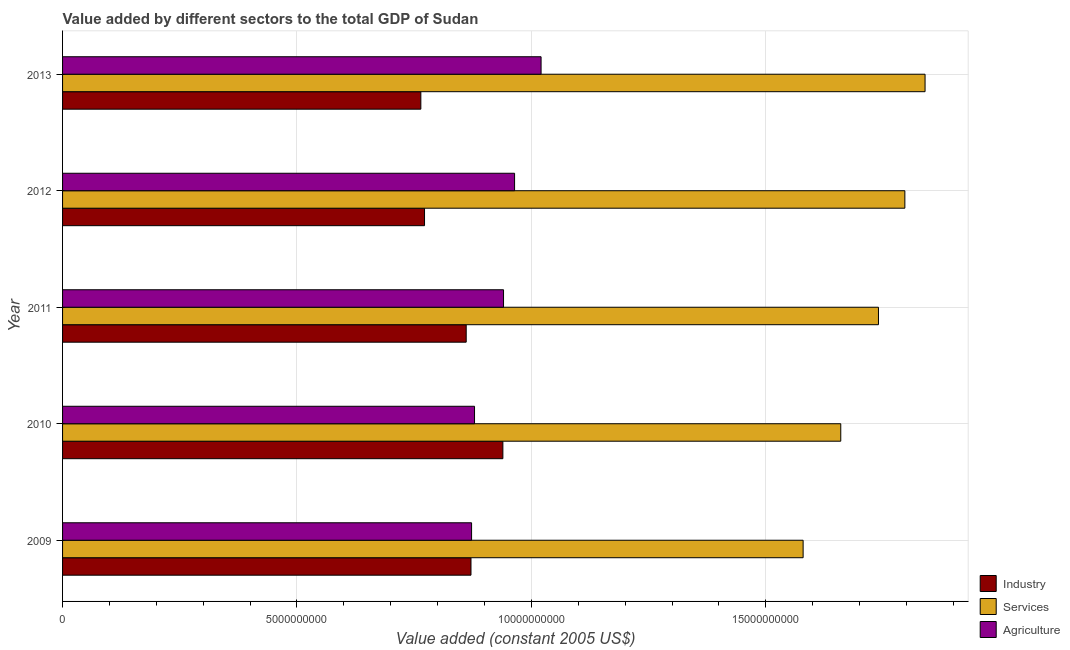How many different coloured bars are there?
Your response must be concise. 3. How many groups of bars are there?
Give a very brief answer. 5. Are the number of bars per tick equal to the number of legend labels?
Your answer should be very brief. Yes. How many bars are there on the 2nd tick from the top?
Your answer should be very brief. 3. What is the label of the 4th group of bars from the top?
Offer a terse response. 2010. In how many cases, is the number of bars for a given year not equal to the number of legend labels?
Make the answer very short. 0. What is the value added by services in 2013?
Provide a short and direct response. 1.84e+1. Across all years, what is the maximum value added by agricultural sector?
Provide a succinct answer. 1.02e+1. Across all years, what is the minimum value added by services?
Give a very brief answer. 1.58e+1. In which year was the value added by services minimum?
Your response must be concise. 2009. What is the total value added by industrial sector in the graph?
Your response must be concise. 4.21e+1. What is the difference between the value added by services in 2011 and that in 2013?
Offer a terse response. -9.94e+08. What is the difference between the value added by agricultural sector in 2010 and the value added by services in 2012?
Give a very brief answer. -9.18e+09. What is the average value added by industrial sector per year?
Keep it short and to the point. 8.41e+09. In the year 2013, what is the difference between the value added by services and value added by industrial sector?
Keep it short and to the point. 1.08e+1. In how many years, is the value added by industrial sector greater than 16000000000 US$?
Your answer should be very brief. 0. Is the difference between the value added by industrial sector in 2010 and 2012 greater than the difference between the value added by services in 2010 and 2012?
Give a very brief answer. Yes. What is the difference between the highest and the second highest value added by services?
Make the answer very short. 4.31e+08. What is the difference between the highest and the lowest value added by agricultural sector?
Offer a very short reply. 1.48e+09. Is the sum of the value added by agricultural sector in 2009 and 2012 greater than the maximum value added by services across all years?
Provide a short and direct response. No. What does the 2nd bar from the top in 2013 represents?
Make the answer very short. Services. What does the 3rd bar from the bottom in 2009 represents?
Your answer should be compact. Agriculture. How many bars are there?
Your response must be concise. 15. How many years are there in the graph?
Provide a short and direct response. 5. Does the graph contain any zero values?
Give a very brief answer. No. How many legend labels are there?
Your answer should be very brief. 3. What is the title of the graph?
Keep it short and to the point. Value added by different sectors to the total GDP of Sudan. What is the label or title of the X-axis?
Make the answer very short. Value added (constant 2005 US$). What is the Value added (constant 2005 US$) of Industry in 2009?
Your response must be concise. 8.71e+09. What is the Value added (constant 2005 US$) in Services in 2009?
Your answer should be compact. 1.58e+1. What is the Value added (constant 2005 US$) in Agriculture in 2009?
Offer a terse response. 8.72e+09. What is the Value added (constant 2005 US$) in Industry in 2010?
Provide a succinct answer. 9.39e+09. What is the Value added (constant 2005 US$) in Services in 2010?
Provide a short and direct response. 1.66e+1. What is the Value added (constant 2005 US$) in Agriculture in 2010?
Ensure brevity in your answer.  8.79e+09. What is the Value added (constant 2005 US$) of Industry in 2011?
Provide a succinct answer. 8.61e+09. What is the Value added (constant 2005 US$) of Services in 2011?
Your answer should be compact. 1.74e+1. What is the Value added (constant 2005 US$) in Agriculture in 2011?
Your answer should be compact. 9.41e+09. What is the Value added (constant 2005 US$) of Industry in 2012?
Offer a terse response. 7.72e+09. What is the Value added (constant 2005 US$) in Services in 2012?
Make the answer very short. 1.80e+1. What is the Value added (constant 2005 US$) in Agriculture in 2012?
Offer a terse response. 9.64e+09. What is the Value added (constant 2005 US$) of Industry in 2013?
Keep it short and to the point. 7.64e+09. What is the Value added (constant 2005 US$) in Services in 2013?
Ensure brevity in your answer.  1.84e+1. What is the Value added (constant 2005 US$) in Agriculture in 2013?
Offer a terse response. 1.02e+1. Across all years, what is the maximum Value added (constant 2005 US$) of Industry?
Your answer should be compact. 9.39e+09. Across all years, what is the maximum Value added (constant 2005 US$) in Services?
Ensure brevity in your answer.  1.84e+1. Across all years, what is the maximum Value added (constant 2005 US$) in Agriculture?
Your answer should be compact. 1.02e+1. Across all years, what is the minimum Value added (constant 2005 US$) in Industry?
Give a very brief answer. 7.64e+09. Across all years, what is the minimum Value added (constant 2005 US$) in Services?
Provide a succinct answer. 1.58e+1. Across all years, what is the minimum Value added (constant 2005 US$) of Agriculture?
Your answer should be compact. 8.72e+09. What is the total Value added (constant 2005 US$) of Industry in the graph?
Your answer should be compact. 4.21e+1. What is the total Value added (constant 2005 US$) in Services in the graph?
Your answer should be very brief. 8.62e+1. What is the total Value added (constant 2005 US$) of Agriculture in the graph?
Offer a terse response. 4.68e+1. What is the difference between the Value added (constant 2005 US$) in Industry in 2009 and that in 2010?
Give a very brief answer. -6.80e+08. What is the difference between the Value added (constant 2005 US$) in Services in 2009 and that in 2010?
Ensure brevity in your answer.  -8.03e+08. What is the difference between the Value added (constant 2005 US$) in Agriculture in 2009 and that in 2010?
Offer a terse response. -6.31e+07. What is the difference between the Value added (constant 2005 US$) in Industry in 2009 and that in 2011?
Offer a terse response. 1.02e+08. What is the difference between the Value added (constant 2005 US$) of Services in 2009 and that in 2011?
Provide a short and direct response. -1.61e+09. What is the difference between the Value added (constant 2005 US$) in Agriculture in 2009 and that in 2011?
Offer a very short reply. -6.81e+08. What is the difference between the Value added (constant 2005 US$) in Industry in 2009 and that in 2012?
Your response must be concise. 9.91e+08. What is the difference between the Value added (constant 2005 US$) in Services in 2009 and that in 2012?
Give a very brief answer. -2.17e+09. What is the difference between the Value added (constant 2005 US$) of Agriculture in 2009 and that in 2012?
Make the answer very short. -9.17e+08. What is the difference between the Value added (constant 2005 US$) in Industry in 2009 and that in 2013?
Provide a short and direct response. 1.07e+09. What is the difference between the Value added (constant 2005 US$) in Services in 2009 and that in 2013?
Keep it short and to the point. -2.60e+09. What is the difference between the Value added (constant 2005 US$) in Agriculture in 2009 and that in 2013?
Your answer should be compact. -1.48e+09. What is the difference between the Value added (constant 2005 US$) in Industry in 2010 and that in 2011?
Make the answer very short. 7.82e+08. What is the difference between the Value added (constant 2005 US$) in Services in 2010 and that in 2011?
Give a very brief answer. -8.04e+08. What is the difference between the Value added (constant 2005 US$) of Agriculture in 2010 and that in 2011?
Ensure brevity in your answer.  -6.18e+08. What is the difference between the Value added (constant 2005 US$) in Industry in 2010 and that in 2012?
Provide a succinct answer. 1.67e+09. What is the difference between the Value added (constant 2005 US$) in Services in 2010 and that in 2012?
Offer a terse response. -1.37e+09. What is the difference between the Value added (constant 2005 US$) of Agriculture in 2010 and that in 2012?
Provide a succinct answer. -8.54e+08. What is the difference between the Value added (constant 2005 US$) of Industry in 2010 and that in 2013?
Your response must be concise. 1.75e+09. What is the difference between the Value added (constant 2005 US$) of Services in 2010 and that in 2013?
Provide a short and direct response. -1.80e+09. What is the difference between the Value added (constant 2005 US$) of Agriculture in 2010 and that in 2013?
Offer a very short reply. -1.42e+09. What is the difference between the Value added (constant 2005 US$) in Industry in 2011 and that in 2012?
Your answer should be compact. 8.89e+08. What is the difference between the Value added (constant 2005 US$) in Services in 2011 and that in 2012?
Your answer should be very brief. -5.63e+08. What is the difference between the Value added (constant 2005 US$) in Agriculture in 2011 and that in 2012?
Your answer should be very brief. -2.36e+08. What is the difference between the Value added (constant 2005 US$) in Industry in 2011 and that in 2013?
Your answer should be very brief. 9.68e+08. What is the difference between the Value added (constant 2005 US$) of Services in 2011 and that in 2013?
Provide a succinct answer. -9.94e+08. What is the difference between the Value added (constant 2005 US$) in Agriculture in 2011 and that in 2013?
Your answer should be very brief. -8.01e+08. What is the difference between the Value added (constant 2005 US$) in Industry in 2012 and that in 2013?
Your answer should be compact. 7.88e+07. What is the difference between the Value added (constant 2005 US$) in Services in 2012 and that in 2013?
Ensure brevity in your answer.  -4.31e+08. What is the difference between the Value added (constant 2005 US$) in Agriculture in 2012 and that in 2013?
Provide a short and direct response. -5.65e+08. What is the difference between the Value added (constant 2005 US$) of Industry in 2009 and the Value added (constant 2005 US$) of Services in 2010?
Make the answer very short. -7.89e+09. What is the difference between the Value added (constant 2005 US$) in Industry in 2009 and the Value added (constant 2005 US$) in Agriculture in 2010?
Your answer should be compact. -7.57e+07. What is the difference between the Value added (constant 2005 US$) of Services in 2009 and the Value added (constant 2005 US$) of Agriculture in 2010?
Give a very brief answer. 7.01e+09. What is the difference between the Value added (constant 2005 US$) in Industry in 2009 and the Value added (constant 2005 US$) in Services in 2011?
Keep it short and to the point. -8.69e+09. What is the difference between the Value added (constant 2005 US$) of Industry in 2009 and the Value added (constant 2005 US$) of Agriculture in 2011?
Give a very brief answer. -6.94e+08. What is the difference between the Value added (constant 2005 US$) of Services in 2009 and the Value added (constant 2005 US$) of Agriculture in 2011?
Your response must be concise. 6.39e+09. What is the difference between the Value added (constant 2005 US$) in Industry in 2009 and the Value added (constant 2005 US$) in Services in 2012?
Give a very brief answer. -9.25e+09. What is the difference between the Value added (constant 2005 US$) of Industry in 2009 and the Value added (constant 2005 US$) of Agriculture in 2012?
Offer a terse response. -9.30e+08. What is the difference between the Value added (constant 2005 US$) in Services in 2009 and the Value added (constant 2005 US$) in Agriculture in 2012?
Offer a very short reply. 6.15e+09. What is the difference between the Value added (constant 2005 US$) of Industry in 2009 and the Value added (constant 2005 US$) of Services in 2013?
Your response must be concise. -9.69e+09. What is the difference between the Value added (constant 2005 US$) of Industry in 2009 and the Value added (constant 2005 US$) of Agriculture in 2013?
Your response must be concise. -1.50e+09. What is the difference between the Value added (constant 2005 US$) of Services in 2009 and the Value added (constant 2005 US$) of Agriculture in 2013?
Provide a succinct answer. 5.59e+09. What is the difference between the Value added (constant 2005 US$) of Industry in 2010 and the Value added (constant 2005 US$) of Services in 2011?
Your response must be concise. -8.01e+09. What is the difference between the Value added (constant 2005 US$) of Industry in 2010 and the Value added (constant 2005 US$) of Agriculture in 2011?
Offer a terse response. -1.40e+07. What is the difference between the Value added (constant 2005 US$) of Services in 2010 and the Value added (constant 2005 US$) of Agriculture in 2011?
Offer a very short reply. 7.19e+09. What is the difference between the Value added (constant 2005 US$) of Industry in 2010 and the Value added (constant 2005 US$) of Services in 2012?
Offer a terse response. -8.57e+09. What is the difference between the Value added (constant 2005 US$) in Industry in 2010 and the Value added (constant 2005 US$) in Agriculture in 2012?
Keep it short and to the point. -2.50e+08. What is the difference between the Value added (constant 2005 US$) of Services in 2010 and the Value added (constant 2005 US$) of Agriculture in 2012?
Your response must be concise. 6.96e+09. What is the difference between the Value added (constant 2005 US$) in Industry in 2010 and the Value added (constant 2005 US$) in Services in 2013?
Give a very brief answer. -9.00e+09. What is the difference between the Value added (constant 2005 US$) of Industry in 2010 and the Value added (constant 2005 US$) of Agriculture in 2013?
Provide a short and direct response. -8.15e+08. What is the difference between the Value added (constant 2005 US$) of Services in 2010 and the Value added (constant 2005 US$) of Agriculture in 2013?
Provide a succinct answer. 6.39e+09. What is the difference between the Value added (constant 2005 US$) of Industry in 2011 and the Value added (constant 2005 US$) of Services in 2012?
Keep it short and to the point. -9.36e+09. What is the difference between the Value added (constant 2005 US$) of Industry in 2011 and the Value added (constant 2005 US$) of Agriculture in 2012?
Provide a short and direct response. -1.03e+09. What is the difference between the Value added (constant 2005 US$) in Services in 2011 and the Value added (constant 2005 US$) in Agriculture in 2012?
Provide a short and direct response. 7.76e+09. What is the difference between the Value added (constant 2005 US$) in Industry in 2011 and the Value added (constant 2005 US$) in Services in 2013?
Your answer should be compact. -9.79e+09. What is the difference between the Value added (constant 2005 US$) of Industry in 2011 and the Value added (constant 2005 US$) of Agriculture in 2013?
Ensure brevity in your answer.  -1.60e+09. What is the difference between the Value added (constant 2005 US$) in Services in 2011 and the Value added (constant 2005 US$) in Agriculture in 2013?
Your answer should be very brief. 7.20e+09. What is the difference between the Value added (constant 2005 US$) of Industry in 2012 and the Value added (constant 2005 US$) of Services in 2013?
Offer a terse response. -1.07e+1. What is the difference between the Value added (constant 2005 US$) of Industry in 2012 and the Value added (constant 2005 US$) of Agriculture in 2013?
Ensure brevity in your answer.  -2.49e+09. What is the difference between the Value added (constant 2005 US$) in Services in 2012 and the Value added (constant 2005 US$) in Agriculture in 2013?
Provide a succinct answer. 7.76e+09. What is the average Value added (constant 2005 US$) in Industry per year?
Give a very brief answer. 8.41e+09. What is the average Value added (constant 2005 US$) in Services per year?
Ensure brevity in your answer.  1.72e+1. What is the average Value added (constant 2005 US$) of Agriculture per year?
Offer a terse response. 9.35e+09. In the year 2009, what is the difference between the Value added (constant 2005 US$) in Industry and Value added (constant 2005 US$) in Services?
Offer a terse response. -7.08e+09. In the year 2009, what is the difference between the Value added (constant 2005 US$) of Industry and Value added (constant 2005 US$) of Agriculture?
Provide a short and direct response. -1.25e+07. In the year 2009, what is the difference between the Value added (constant 2005 US$) of Services and Value added (constant 2005 US$) of Agriculture?
Provide a short and direct response. 7.07e+09. In the year 2010, what is the difference between the Value added (constant 2005 US$) of Industry and Value added (constant 2005 US$) of Services?
Your response must be concise. -7.21e+09. In the year 2010, what is the difference between the Value added (constant 2005 US$) of Industry and Value added (constant 2005 US$) of Agriculture?
Offer a very short reply. 6.04e+08. In the year 2010, what is the difference between the Value added (constant 2005 US$) of Services and Value added (constant 2005 US$) of Agriculture?
Ensure brevity in your answer.  7.81e+09. In the year 2011, what is the difference between the Value added (constant 2005 US$) of Industry and Value added (constant 2005 US$) of Services?
Make the answer very short. -8.79e+09. In the year 2011, what is the difference between the Value added (constant 2005 US$) in Industry and Value added (constant 2005 US$) in Agriculture?
Offer a terse response. -7.96e+08. In the year 2011, what is the difference between the Value added (constant 2005 US$) in Services and Value added (constant 2005 US$) in Agriculture?
Offer a very short reply. 8.00e+09. In the year 2012, what is the difference between the Value added (constant 2005 US$) in Industry and Value added (constant 2005 US$) in Services?
Your response must be concise. -1.02e+1. In the year 2012, what is the difference between the Value added (constant 2005 US$) in Industry and Value added (constant 2005 US$) in Agriculture?
Your answer should be compact. -1.92e+09. In the year 2012, what is the difference between the Value added (constant 2005 US$) in Services and Value added (constant 2005 US$) in Agriculture?
Your response must be concise. 8.32e+09. In the year 2013, what is the difference between the Value added (constant 2005 US$) of Industry and Value added (constant 2005 US$) of Services?
Offer a terse response. -1.08e+1. In the year 2013, what is the difference between the Value added (constant 2005 US$) of Industry and Value added (constant 2005 US$) of Agriculture?
Make the answer very short. -2.56e+09. In the year 2013, what is the difference between the Value added (constant 2005 US$) of Services and Value added (constant 2005 US$) of Agriculture?
Your answer should be very brief. 8.19e+09. What is the ratio of the Value added (constant 2005 US$) of Industry in 2009 to that in 2010?
Make the answer very short. 0.93. What is the ratio of the Value added (constant 2005 US$) of Services in 2009 to that in 2010?
Your answer should be very brief. 0.95. What is the ratio of the Value added (constant 2005 US$) of Industry in 2009 to that in 2011?
Provide a succinct answer. 1.01. What is the ratio of the Value added (constant 2005 US$) of Services in 2009 to that in 2011?
Provide a succinct answer. 0.91. What is the ratio of the Value added (constant 2005 US$) in Agriculture in 2009 to that in 2011?
Ensure brevity in your answer.  0.93. What is the ratio of the Value added (constant 2005 US$) of Industry in 2009 to that in 2012?
Give a very brief answer. 1.13. What is the ratio of the Value added (constant 2005 US$) of Services in 2009 to that in 2012?
Your answer should be very brief. 0.88. What is the ratio of the Value added (constant 2005 US$) in Agriculture in 2009 to that in 2012?
Offer a terse response. 0.9. What is the ratio of the Value added (constant 2005 US$) of Industry in 2009 to that in 2013?
Provide a short and direct response. 1.14. What is the ratio of the Value added (constant 2005 US$) of Services in 2009 to that in 2013?
Offer a very short reply. 0.86. What is the ratio of the Value added (constant 2005 US$) in Agriculture in 2009 to that in 2013?
Provide a short and direct response. 0.85. What is the ratio of the Value added (constant 2005 US$) in Industry in 2010 to that in 2011?
Give a very brief answer. 1.09. What is the ratio of the Value added (constant 2005 US$) of Services in 2010 to that in 2011?
Offer a terse response. 0.95. What is the ratio of the Value added (constant 2005 US$) in Agriculture in 2010 to that in 2011?
Give a very brief answer. 0.93. What is the ratio of the Value added (constant 2005 US$) of Industry in 2010 to that in 2012?
Your response must be concise. 1.22. What is the ratio of the Value added (constant 2005 US$) in Services in 2010 to that in 2012?
Offer a terse response. 0.92. What is the ratio of the Value added (constant 2005 US$) of Agriculture in 2010 to that in 2012?
Give a very brief answer. 0.91. What is the ratio of the Value added (constant 2005 US$) in Industry in 2010 to that in 2013?
Make the answer very short. 1.23. What is the ratio of the Value added (constant 2005 US$) in Services in 2010 to that in 2013?
Ensure brevity in your answer.  0.9. What is the ratio of the Value added (constant 2005 US$) in Agriculture in 2010 to that in 2013?
Ensure brevity in your answer.  0.86. What is the ratio of the Value added (constant 2005 US$) in Industry in 2011 to that in 2012?
Keep it short and to the point. 1.12. What is the ratio of the Value added (constant 2005 US$) of Services in 2011 to that in 2012?
Give a very brief answer. 0.97. What is the ratio of the Value added (constant 2005 US$) of Agriculture in 2011 to that in 2012?
Provide a succinct answer. 0.98. What is the ratio of the Value added (constant 2005 US$) in Industry in 2011 to that in 2013?
Offer a terse response. 1.13. What is the ratio of the Value added (constant 2005 US$) in Services in 2011 to that in 2013?
Provide a short and direct response. 0.95. What is the ratio of the Value added (constant 2005 US$) of Agriculture in 2011 to that in 2013?
Offer a very short reply. 0.92. What is the ratio of the Value added (constant 2005 US$) of Industry in 2012 to that in 2013?
Your answer should be very brief. 1.01. What is the ratio of the Value added (constant 2005 US$) in Services in 2012 to that in 2013?
Give a very brief answer. 0.98. What is the ratio of the Value added (constant 2005 US$) of Agriculture in 2012 to that in 2013?
Your response must be concise. 0.94. What is the difference between the highest and the second highest Value added (constant 2005 US$) in Industry?
Keep it short and to the point. 6.80e+08. What is the difference between the highest and the second highest Value added (constant 2005 US$) in Services?
Give a very brief answer. 4.31e+08. What is the difference between the highest and the second highest Value added (constant 2005 US$) in Agriculture?
Ensure brevity in your answer.  5.65e+08. What is the difference between the highest and the lowest Value added (constant 2005 US$) in Industry?
Keep it short and to the point. 1.75e+09. What is the difference between the highest and the lowest Value added (constant 2005 US$) of Services?
Ensure brevity in your answer.  2.60e+09. What is the difference between the highest and the lowest Value added (constant 2005 US$) of Agriculture?
Make the answer very short. 1.48e+09. 